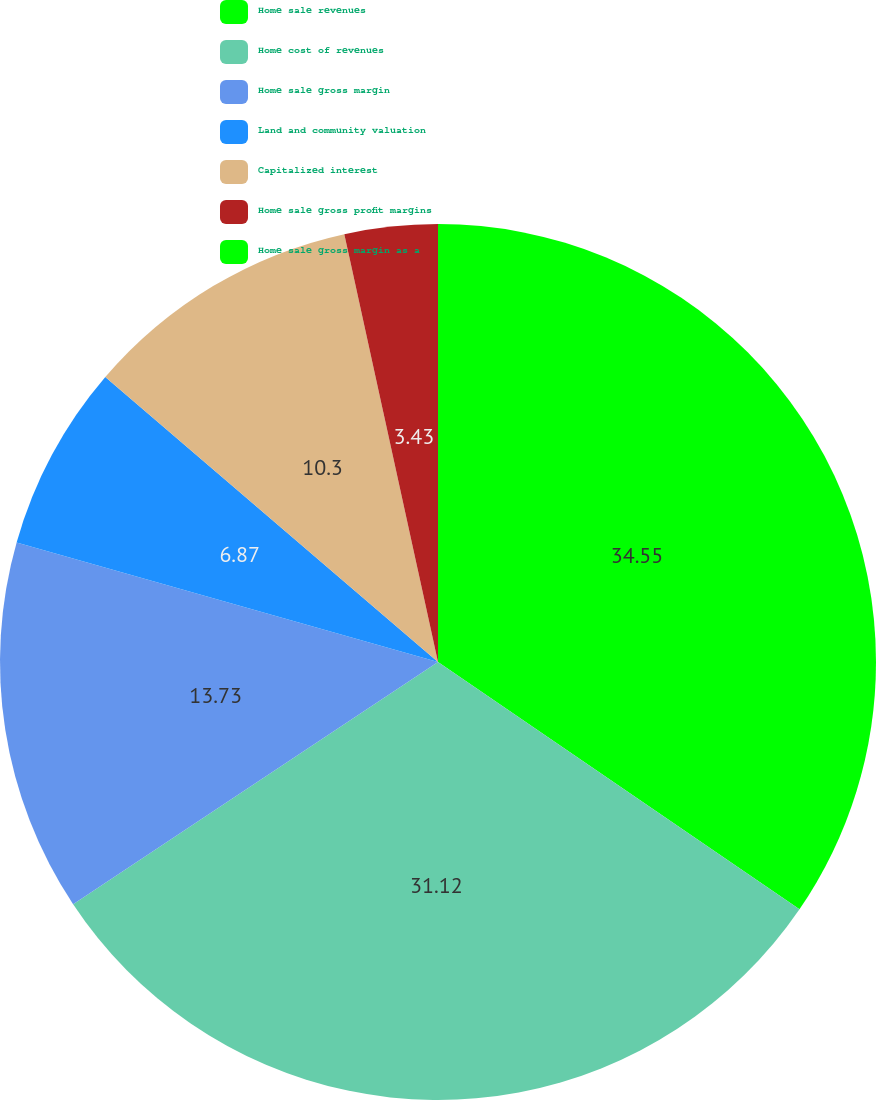Convert chart to OTSL. <chart><loc_0><loc_0><loc_500><loc_500><pie_chart><fcel>Home sale revenues<fcel>Home cost of revenues<fcel>Home sale gross margin<fcel>Land and community valuation<fcel>Capitalized interest<fcel>Home sale gross profit margins<fcel>Home sale gross margin as a<nl><fcel>34.55%<fcel>31.12%<fcel>13.73%<fcel>6.87%<fcel>10.3%<fcel>3.43%<fcel>0.0%<nl></chart> 